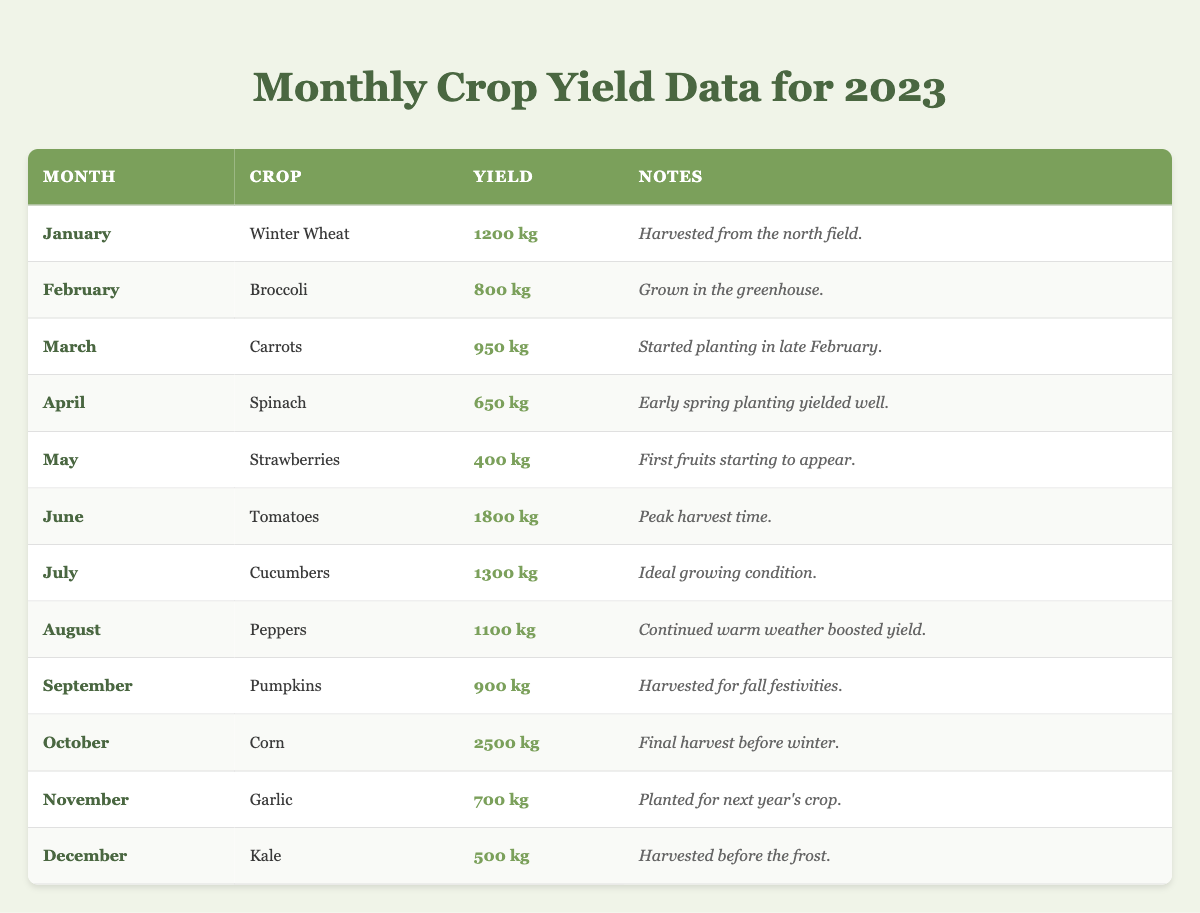What was the crop with the highest yield in 2023? By examining the table, I can see that "Corn" in October had the highest yield at 2500 kg.
Answer: Corn How many kilograms of Spinach were harvested in April? The table specifies that the yield of Spinach in April was 650 kg.
Answer: 650 kg In which month were the first strawberries harvested? The table indicates that Strawberries were harvested in May, as noted by the corresponding yield entry.
Answer: May What is the total yield of all crops harvested from January to June? Adding the yields from January (1200 kg), February (800 kg), March (950 kg), April (650 kg), May (400 kg), and June (1800 kg) gives 1200 + 800 + 950 + 650 + 400 + 1800 = 4850 kg.
Answer: 4850 kg How much more yield did Corn produce than Broccoli? The yield for Corn is 2500 kg (October) and for Broccoli is 800 kg (February). The difference is 2500 - 800 = 1700 kg.
Answer: 1700 kg What was the average yield from July to September? The crops from July (Cucumbers, 1300 kg), August (Peppers, 1100 kg), and September (Pumpkins, 900 kg) give a total yield of 1300 + 1100 + 900 = 3300 kg. There are 3 months, so the average is 3300/3 = 1100 kg.
Answer: 1100 kg Did the yield of Kale exceed that of Strawberries? The yield for Kale in December is 500 kg and for Strawberries in May is 400 kg. Since 500 kg > 400 kg, the statement is true.
Answer: Yes Which month had a noteworthy increase in yield actions compared to the previous month? By comparing yields between June (1800 kg) and July (1300 kg) and observing the drop from June to July, we notice an increase from April (650 kg) to May (400 kg) as well. The biggest noteworthy increase is from May to June (400 kg to 1800 kg).
Answer: June What is the total yield for the months that had crops starting with the letter 'S'? The crops starting with 'S' are Spinach (650 kg in April) and Strawberries (400 kg in May). Their total is 650 + 400 = 1050 kg.
Answer: 1050 kg Which residue was noted for December's crop? The table shows that Kale was harvested in December and the notes specify that it was harvested before the frost.
Answer: Harvested before the frost 